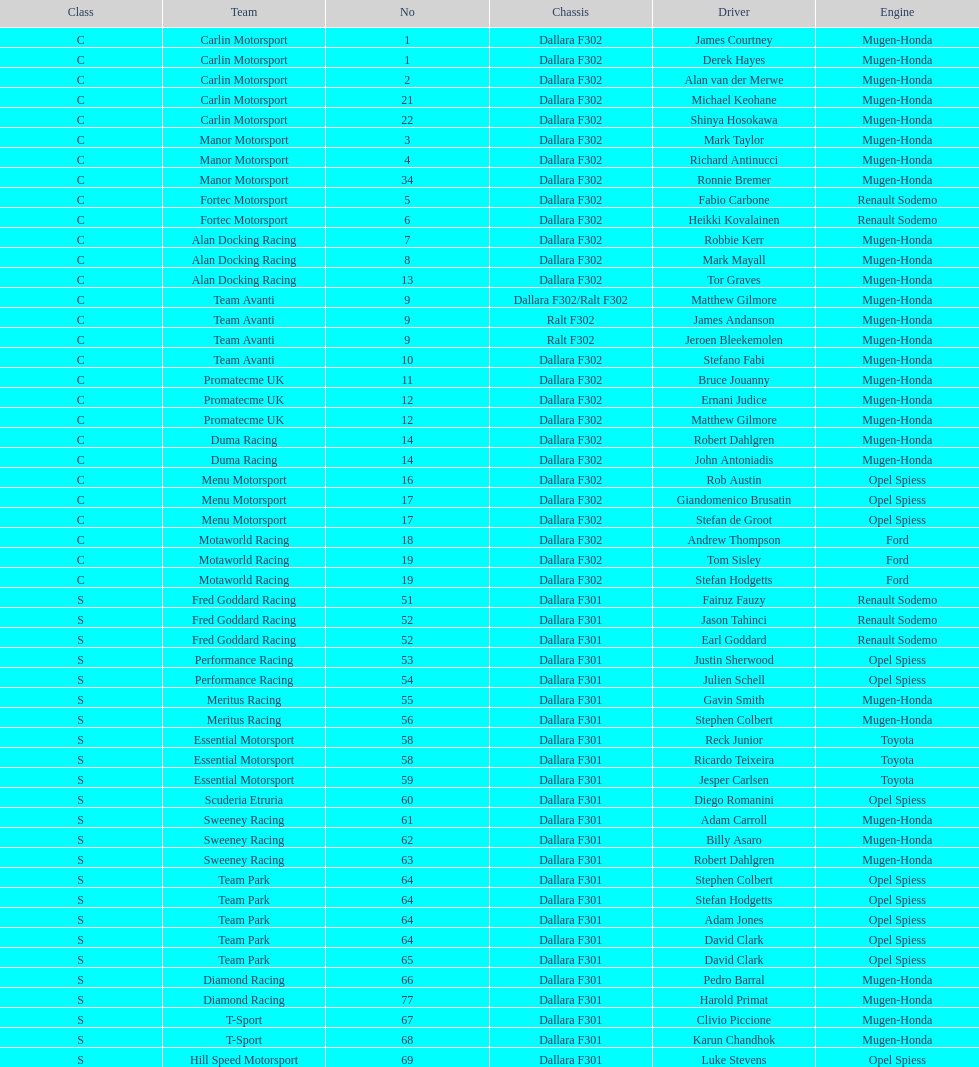How many class s (scholarship) teams are on the chart? 19. 